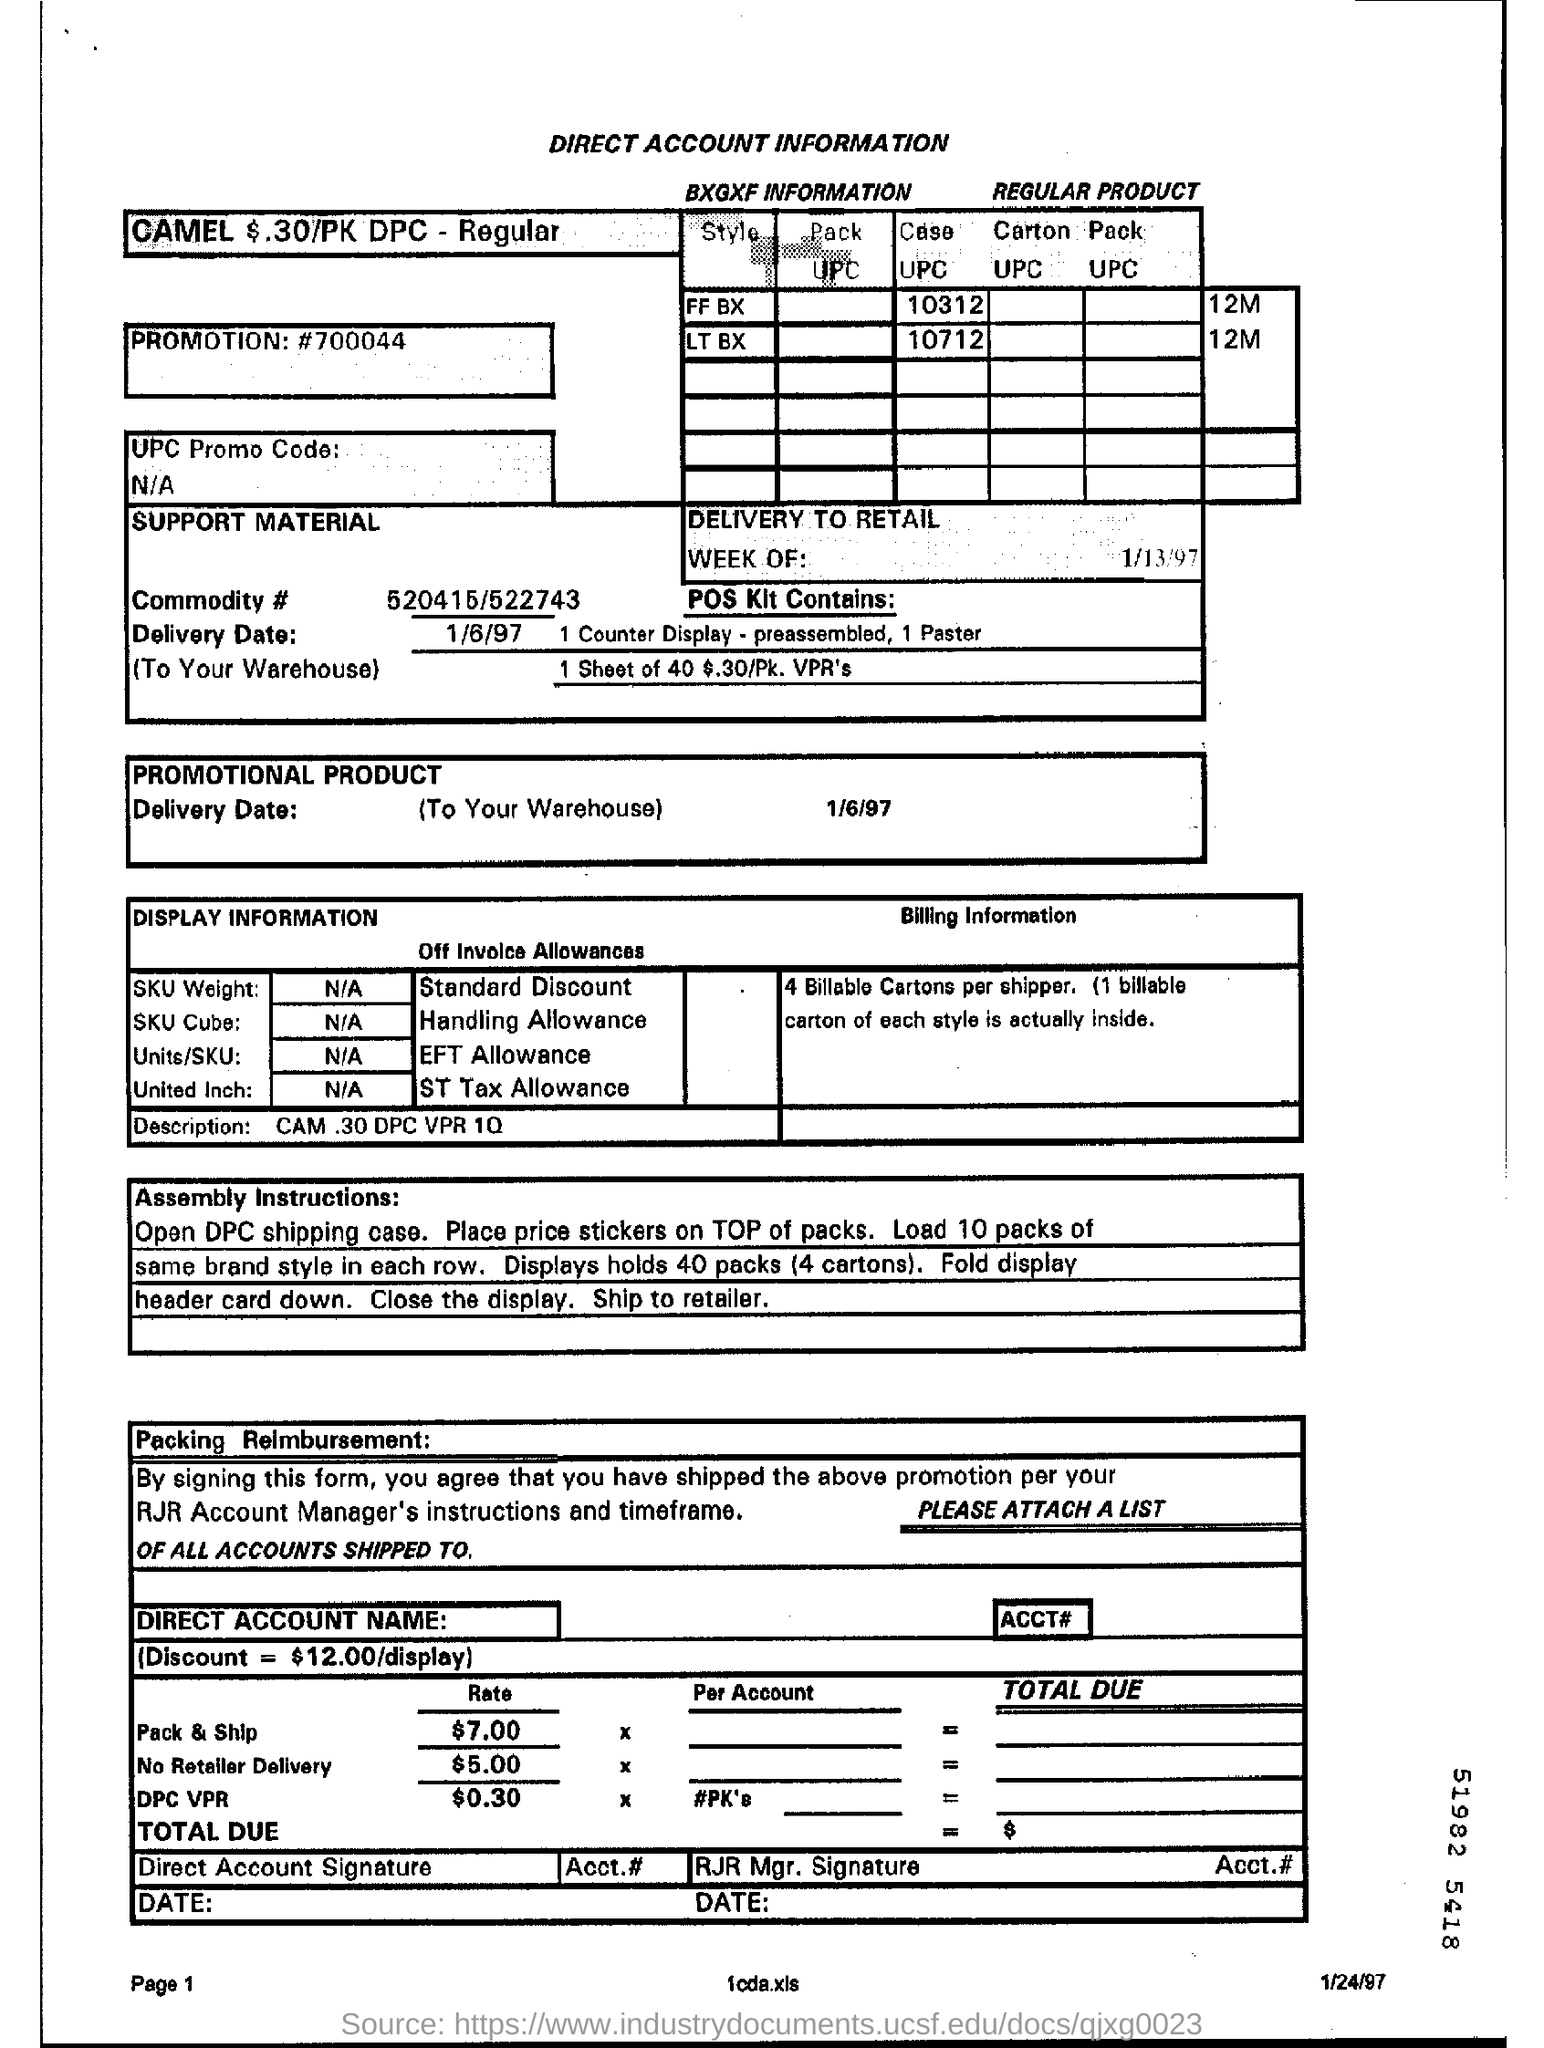What is the delivery date mentioned ?
Provide a succinct answer. 1/6/97. What is the promotion no. mentioned ?
Offer a terse response. 700044. What is the rate mentioned for pack & ship ?
Make the answer very short. $7.00. What is the rate mentioned for no retailer delivery ?
Provide a succinct answer. $5.00. 